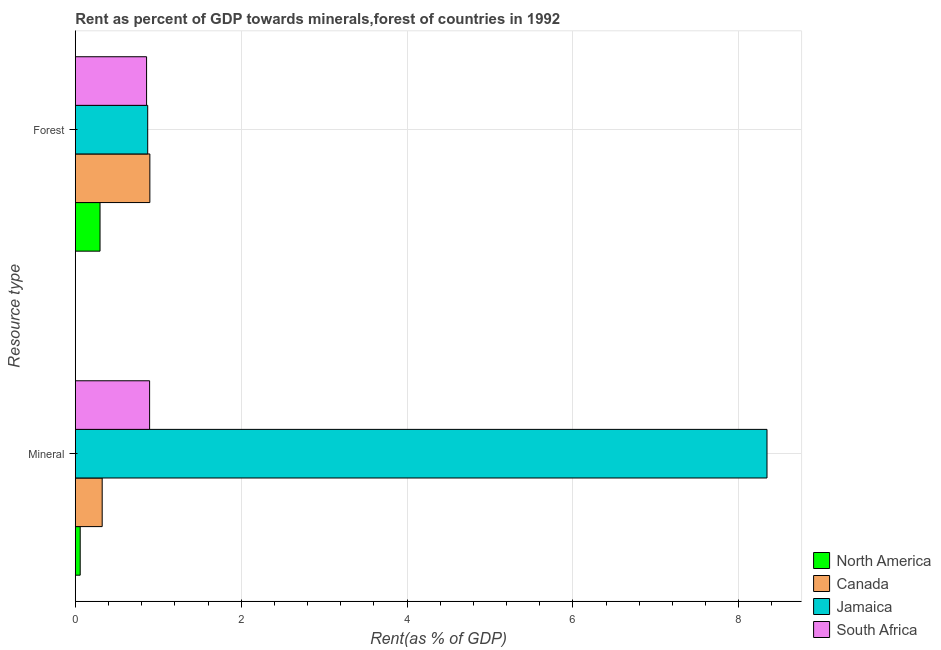How many different coloured bars are there?
Your answer should be very brief. 4. How many groups of bars are there?
Keep it short and to the point. 2. How many bars are there on the 1st tick from the bottom?
Give a very brief answer. 4. What is the label of the 1st group of bars from the top?
Keep it short and to the point. Forest. What is the forest rent in Jamaica?
Keep it short and to the point. 0.87. Across all countries, what is the maximum mineral rent?
Make the answer very short. 8.34. Across all countries, what is the minimum mineral rent?
Provide a succinct answer. 0.06. In which country was the mineral rent minimum?
Your response must be concise. North America. What is the total mineral rent in the graph?
Give a very brief answer. 9.62. What is the difference between the mineral rent in North America and that in Jamaica?
Provide a short and direct response. -8.28. What is the difference between the forest rent in Jamaica and the mineral rent in South Africa?
Keep it short and to the point. -0.02. What is the average mineral rent per country?
Offer a very short reply. 2.4. What is the difference between the mineral rent and forest rent in South Africa?
Your response must be concise. 0.04. In how many countries, is the mineral rent greater than 5.2 %?
Your answer should be very brief. 1. What is the ratio of the mineral rent in Jamaica to that in South Africa?
Give a very brief answer. 9.31. Is the forest rent in North America less than that in Jamaica?
Keep it short and to the point. Yes. In how many countries, is the forest rent greater than the average forest rent taken over all countries?
Your response must be concise. 3. What does the 1st bar from the top in Mineral represents?
Your answer should be compact. South Africa. What does the 3rd bar from the bottom in Forest represents?
Give a very brief answer. Jamaica. How many bars are there?
Keep it short and to the point. 8. Are the values on the major ticks of X-axis written in scientific E-notation?
Provide a succinct answer. No. How many legend labels are there?
Offer a very short reply. 4. How are the legend labels stacked?
Make the answer very short. Vertical. What is the title of the graph?
Provide a short and direct response. Rent as percent of GDP towards minerals,forest of countries in 1992. Does "Micronesia" appear as one of the legend labels in the graph?
Make the answer very short. No. What is the label or title of the X-axis?
Offer a very short reply. Rent(as % of GDP). What is the label or title of the Y-axis?
Your answer should be very brief. Resource type. What is the Rent(as % of GDP) of North America in Mineral?
Make the answer very short. 0.06. What is the Rent(as % of GDP) of Canada in Mineral?
Your answer should be compact. 0.32. What is the Rent(as % of GDP) of Jamaica in Mineral?
Provide a short and direct response. 8.34. What is the Rent(as % of GDP) in South Africa in Mineral?
Provide a succinct answer. 0.9. What is the Rent(as % of GDP) in North America in Forest?
Ensure brevity in your answer.  0.3. What is the Rent(as % of GDP) of Canada in Forest?
Give a very brief answer. 0.9. What is the Rent(as % of GDP) in Jamaica in Forest?
Offer a very short reply. 0.87. What is the Rent(as % of GDP) in South Africa in Forest?
Provide a succinct answer. 0.86. Across all Resource type, what is the maximum Rent(as % of GDP) in North America?
Make the answer very short. 0.3. Across all Resource type, what is the maximum Rent(as % of GDP) in Canada?
Your answer should be very brief. 0.9. Across all Resource type, what is the maximum Rent(as % of GDP) in Jamaica?
Make the answer very short. 8.34. Across all Resource type, what is the maximum Rent(as % of GDP) of South Africa?
Provide a succinct answer. 0.9. Across all Resource type, what is the minimum Rent(as % of GDP) of North America?
Offer a terse response. 0.06. Across all Resource type, what is the minimum Rent(as % of GDP) of Canada?
Make the answer very short. 0.32. Across all Resource type, what is the minimum Rent(as % of GDP) in Jamaica?
Offer a terse response. 0.87. Across all Resource type, what is the minimum Rent(as % of GDP) in South Africa?
Offer a terse response. 0.86. What is the total Rent(as % of GDP) in North America in the graph?
Give a very brief answer. 0.36. What is the total Rent(as % of GDP) in Canada in the graph?
Provide a succinct answer. 1.22. What is the total Rent(as % of GDP) of Jamaica in the graph?
Provide a succinct answer. 9.21. What is the total Rent(as % of GDP) in South Africa in the graph?
Offer a very short reply. 1.76. What is the difference between the Rent(as % of GDP) in North America in Mineral and that in Forest?
Provide a succinct answer. -0.24. What is the difference between the Rent(as % of GDP) of Canada in Mineral and that in Forest?
Your answer should be compact. -0.57. What is the difference between the Rent(as % of GDP) of Jamaica in Mineral and that in Forest?
Give a very brief answer. 7.47. What is the difference between the Rent(as % of GDP) in South Africa in Mineral and that in Forest?
Provide a succinct answer. 0.04. What is the difference between the Rent(as % of GDP) of North America in Mineral and the Rent(as % of GDP) of Canada in Forest?
Offer a terse response. -0.84. What is the difference between the Rent(as % of GDP) of North America in Mineral and the Rent(as % of GDP) of Jamaica in Forest?
Offer a terse response. -0.81. What is the difference between the Rent(as % of GDP) of North America in Mineral and the Rent(as % of GDP) of South Africa in Forest?
Your answer should be compact. -0.8. What is the difference between the Rent(as % of GDP) of Canada in Mineral and the Rent(as % of GDP) of Jamaica in Forest?
Make the answer very short. -0.55. What is the difference between the Rent(as % of GDP) in Canada in Mineral and the Rent(as % of GDP) in South Africa in Forest?
Provide a short and direct response. -0.54. What is the difference between the Rent(as % of GDP) in Jamaica in Mineral and the Rent(as % of GDP) in South Africa in Forest?
Your answer should be compact. 7.48. What is the average Rent(as % of GDP) of North America per Resource type?
Your answer should be compact. 0.18. What is the average Rent(as % of GDP) in Canada per Resource type?
Your answer should be very brief. 0.61. What is the average Rent(as % of GDP) of Jamaica per Resource type?
Provide a short and direct response. 4.61. What is the average Rent(as % of GDP) in South Africa per Resource type?
Keep it short and to the point. 0.88. What is the difference between the Rent(as % of GDP) in North America and Rent(as % of GDP) in Canada in Mineral?
Your answer should be very brief. -0.27. What is the difference between the Rent(as % of GDP) of North America and Rent(as % of GDP) of Jamaica in Mineral?
Keep it short and to the point. -8.28. What is the difference between the Rent(as % of GDP) of North America and Rent(as % of GDP) of South Africa in Mineral?
Keep it short and to the point. -0.84. What is the difference between the Rent(as % of GDP) in Canada and Rent(as % of GDP) in Jamaica in Mineral?
Offer a terse response. -8.02. What is the difference between the Rent(as % of GDP) of Canada and Rent(as % of GDP) of South Africa in Mineral?
Make the answer very short. -0.57. What is the difference between the Rent(as % of GDP) of Jamaica and Rent(as % of GDP) of South Africa in Mineral?
Your answer should be compact. 7.44. What is the difference between the Rent(as % of GDP) of North America and Rent(as % of GDP) of Canada in Forest?
Offer a very short reply. -0.6. What is the difference between the Rent(as % of GDP) of North America and Rent(as % of GDP) of Jamaica in Forest?
Give a very brief answer. -0.57. What is the difference between the Rent(as % of GDP) in North America and Rent(as % of GDP) in South Africa in Forest?
Ensure brevity in your answer.  -0.56. What is the difference between the Rent(as % of GDP) of Canada and Rent(as % of GDP) of Jamaica in Forest?
Your answer should be compact. 0.03. What is the difference between the Rent(as % of GDP) of Canada and Rent(as % of GDP) of South Africa in Forest?
Keep it short and to the point. 0.04. What is the difference between the Rent(as % of GDP) of Jamaica and Rent(as % of GDP) of South Africa in Forest?
Provide a succinct answer. 0.01. What is the ratio of the Rent(as % of GDP) in North America in Mineral to that in Forest?
Your answer should be very brief. 0.2. What is the ratio of the Rent(as % of GDP) in Canada in Mineral to that in Forest?
Provide a succinct answer. 0.36. What is the ratio of the Rent(as % of GDP) in Jamaica in Mineral to that in Forest?
Provide a succinct answer. 9.55. What is the ratio of the Rent(as % of GDP) in South Africa in Mineral to that in Forest?
Keep it short and to the point. 1.04. What is the difference between the highest and the second highest Rent(as % of GDP) of North America?
Provide a short and direct response. 0.24. What is the difference between the highest and the second highest Rent(as % of GDP) of Canada?
Provide a short and direct response. 0.57. What is the difference between the highest and the second highest Rent(as % of GDP) in Jamaica?
Ensure brevity in your answer.  7.47. What is the difference between the highest and the second highest Rent(as % of GDP) of South Africa?
Provide a succinct answer. 0.04. What is the difference between the highest and the lowest Rent(as % of GDP) of North America?
Your answer should be compact. 0.24. What is the difference between the highest and the lowest Rent(as % of GDP) in Canada?
Ensure brevity in your answer.  0.57. What is the difference between the highest and the lowest Rent(as % of GDP) in Jamaica?
Provide a succinct answer. 7.47. What is the difference between the highest and the lowest Rent(as % of GDP) of South Africa?
Your response must be concise. 0.04. 